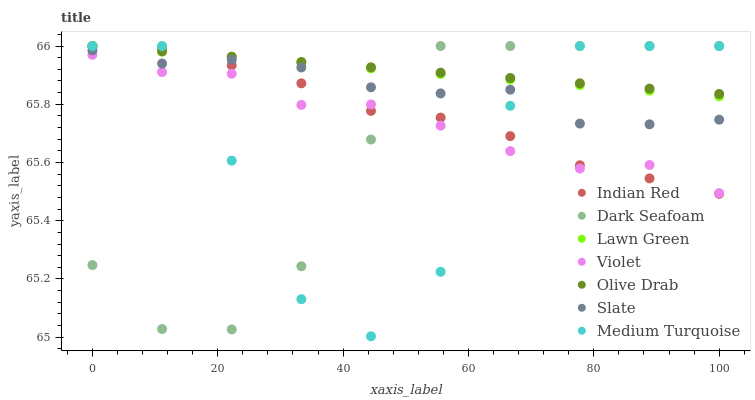Does Dark Seafoam have the minimum area under the curve?
Answer yes or no. Yes. Does Olive Drab have the maximum area under the curve?
Answer yes or no. Yes. Does Medium Turquoise have the minimum area under the curve?
Answer yes or no. No. Does Medium Turquoise have the maximum area under the curve?
Answer yes or no. No. Is Lawn Green the smoothest?
Answer yes or no. Yes. Is Medium Turquoise the roughest?
Answer yes or no. Yes. Is Slate the smoothest?
Answer yes or no. No. Is Slate the roughest?
Answer yes or no. No. Does Medium Turquoise have the lowest value?
Answer yes or no. Yes. Does Slate have the lowest value?
Answer yes or no. No. Does Olive Drab have the highest value?
Answer yes or no. Yes. Does Slate have the highest value?
Answer yes or no. No. Is Violet less than Slate?
Answer yes or no. Yes. Is Olive Drab greater than Violet?
Answer yes or no. Yes. Does Olive Drab intersect Indian Red?
Answer yes or no. Yes. Is Olive Drab less than Indian Red?
Answer yes or no. No. Is Olive Drab greater than Indian Red?
Answer yes or no. No. Does Violet intersect Slate?
Answer yes or no. No. 